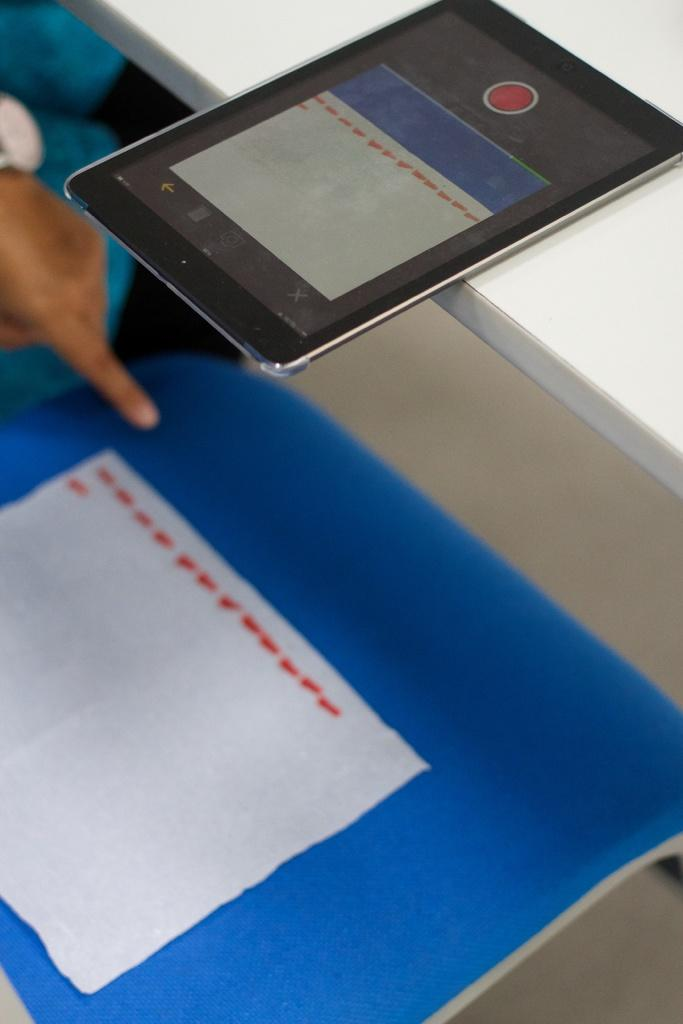What part of a person can be seen in the image? There is a person's hand in the image. What is the person's hand holding or interacting with? There is a tab in the image, which the person's hand is likely interacting with. What type of material is visible in the image? There is paper in the image. Can you describe any other objects in the image? There are some unspecified objects in the image. How does the person plan to cook the boat in the image? There is no boat present in the image, and therefore no cooking or boats are relevant to the conversation. 